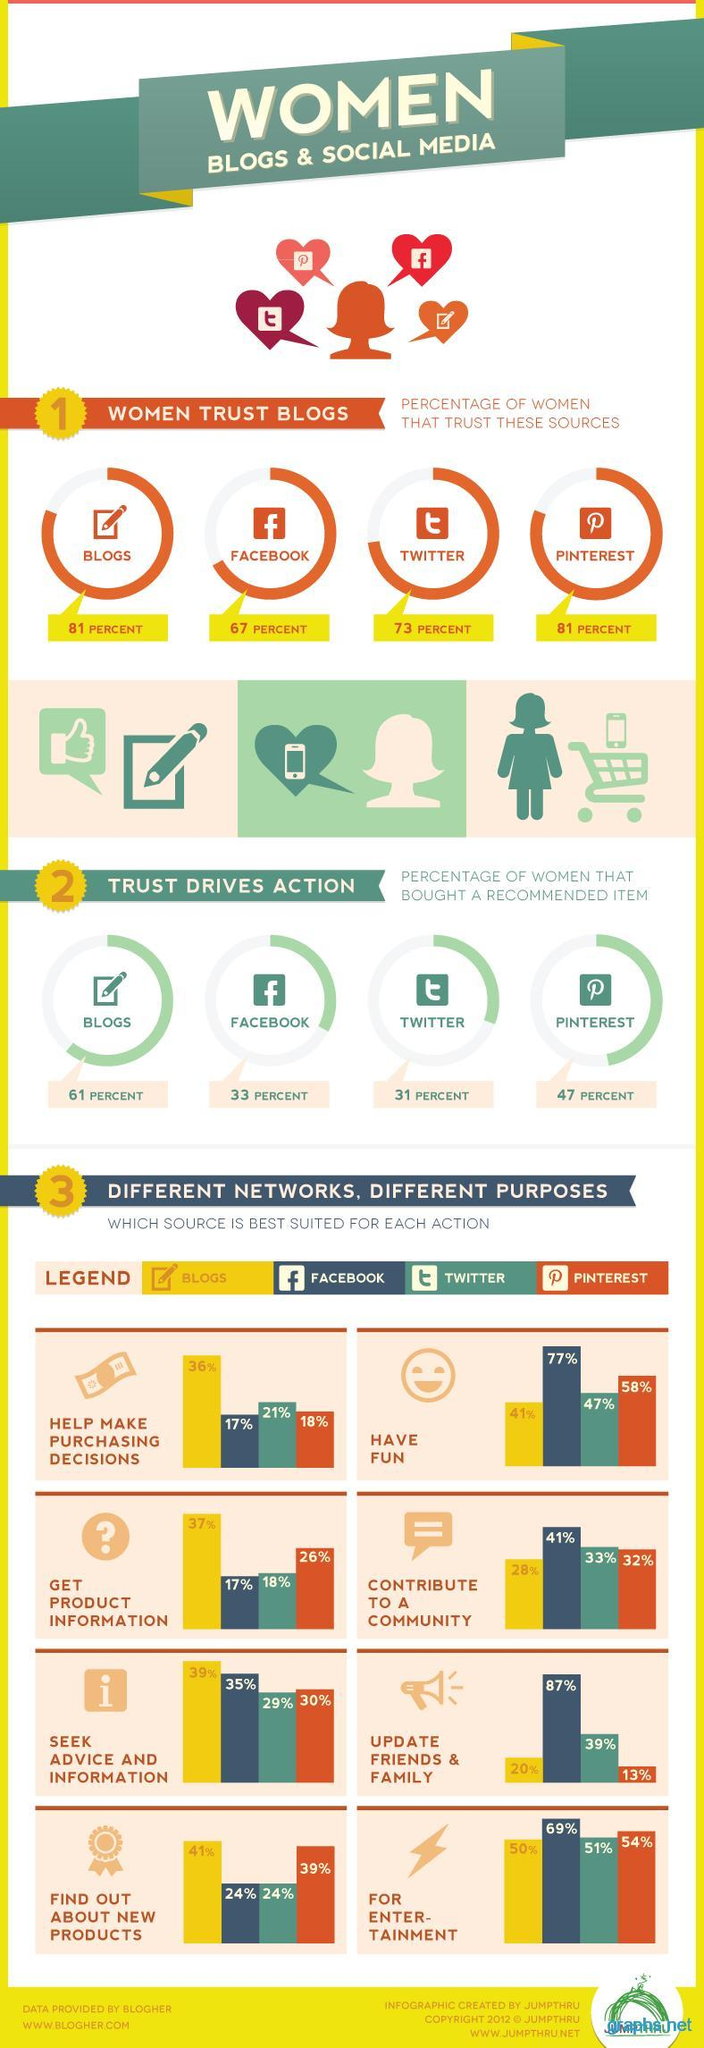What percent of women bought a recommended item on Facebook?
Answer the question with a short phrase. 33 percent Which platform was used by 36% of women to help make purchasing decisions? blogs What percent of women used blogs to find out about new products? 41% Which platform was used by 54% of women for entertainment? Pinterest What percent of women trust blogs? 81 percent Which platform was used by highest percent of women to update family and friends? Facebook What percent of women bought a recommended item on Pinterest? 47 percent What percent of women used Facebook to contribute to a community? 41% Which platform was used by 77% of women to have fun? Facebook Which is trusted by more number of women - Facebook or Twitter? Twitter 